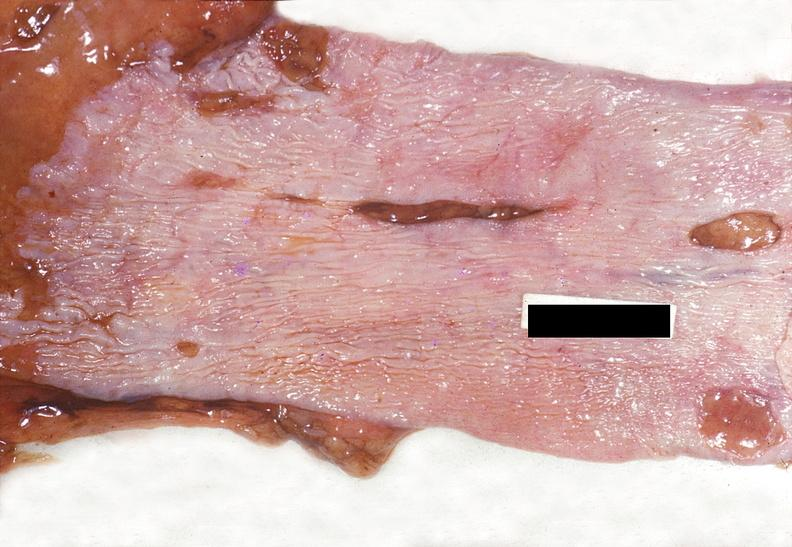does cachexia show esophagus, mallory-weiss tears?
Answer the question using a single word or phrase. No 